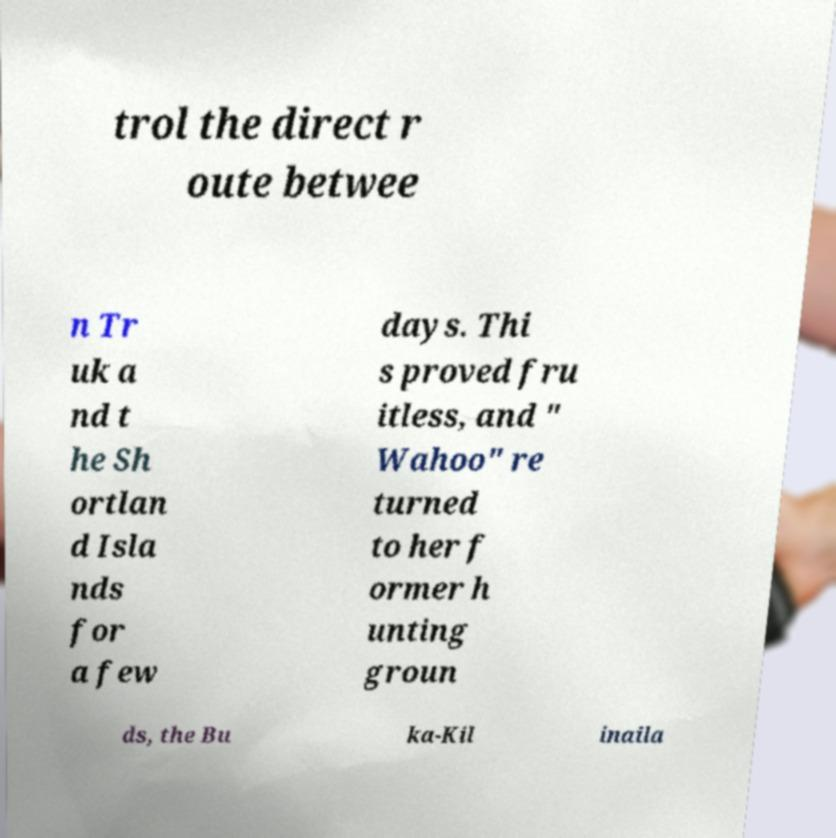Please identify and transcribe the text found in this image. trol the direct r oute betwee n Tr uk a nd t he Sh ortlan d Isla nds for a few days. Thi s proved fru itless, and " Wahoo" re turned to her f ormer h unting groun ds, the Bu ka-Kil inaila 